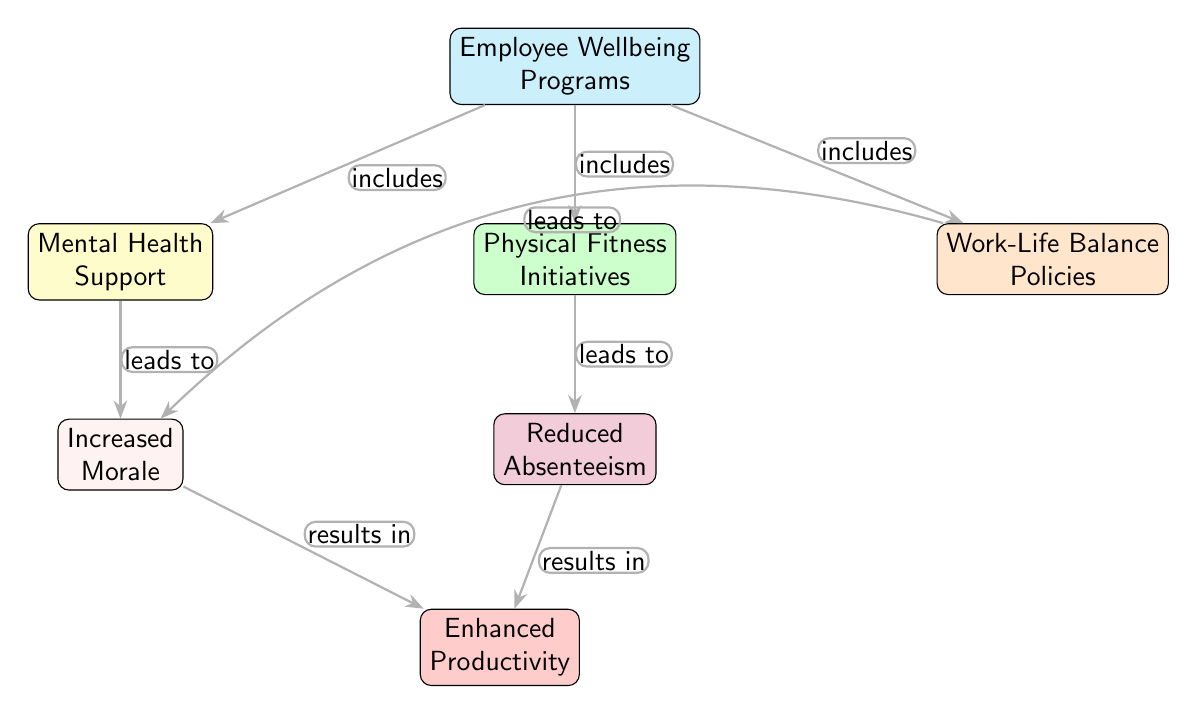What is the main concept represented at the top of the diagram? The main concept is located at the top node, which is labeled as "Employee Wellbeing Programs." This is the starting point of the food chain diagram.
Answer: Employee Wellbeing Programs How many nodes are in the diagram? To find the number of nodes, count each individual box in the diagram. There are eight nodes: Employee Wellbeing Programs, Mental Health Support, Physical Fitness Initiatives, Work-Life Balance Policies, Increased Morale, Reduced Absenteeism, Enhanced Productivity.
Answer: Eight Which node directly leads to Enhanced Productivity? The nodes that lead directly to "Enhanced Productivity" are "Increased Morale" and "Reduced Absenteeism." This means both of these nodes have a directional edge pointing to the Enhanced Productivity node.
Answer: Increased Morale, Reduced Absenteeism What type of relationships are established between Mental Health Support and Increased Morale? The relationship is labeled as "leads to," indicating that Mental Health Support has an influence on Increased Morale. This means support for mental health is understood to enhance employee morale.
Answer: leads to How do Work-Life Balance Policies influence employee morale? Work-Life Balance Policies lead to Increased Morale, as indicated by the edge labeled "leads to," thus showing that having proper work-life policies contributes positively to employee morale.
Answer: leads to Increased Morale What is the relationship between Reduced Absenteeism and Enhanced Productivity? The relationship is also labeled "results in," meaning Reduced Absenteeism contributes positively to achieving Enhanced Productivity, indicating that when absenteeism is lower, productivity is likely to be higher.
Answer: results in Enhanced Productivity Which program directly correlates with Physical Fitness Initiatives? Physical Fitness Initiatives are included under the main concept of Employee Wellbeing Programs. Thus, they are examples of the types of programs designed to enhance employee well-being.
Answer: includes Which elements together contribute to Enhanced Productivity? The contributing elements include Increased Morale (from Mental Health Support and Work-Life Balance Policies) and Reduced Absenteeism (from Physical Fitness Initiatives). The combination of these two categories leads to Enhanced Productivity.
Answer: Increased Morale and Reduced Absenteeism 